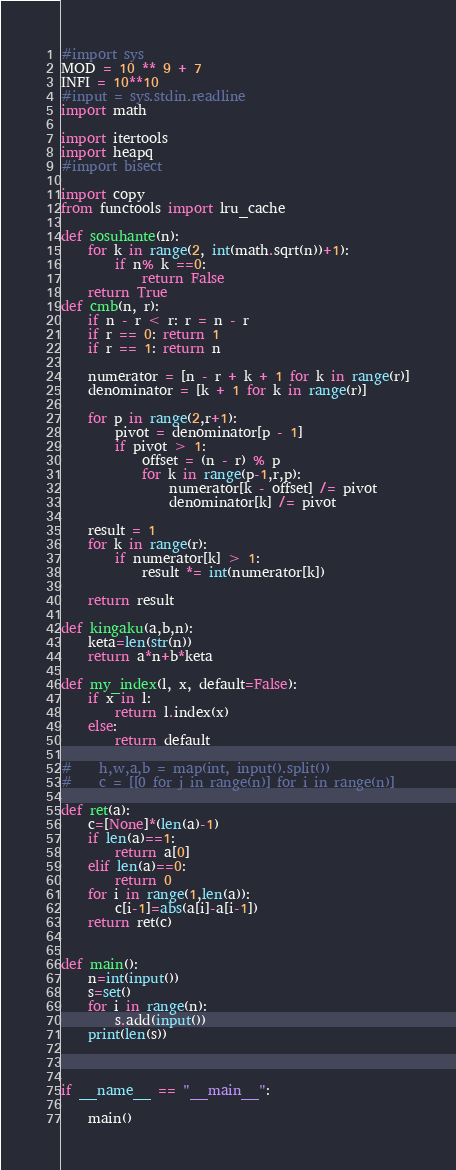Convert code to text. <code><loc_0><loc_0><loc_500><loc_500><_Python_>#import sys
MOD = 10 ** 9 + 7
INFI = 10**10
#input = sys.stdin.readline
import math

import itertools
import heapq
#import bisect

import copy
from functools import lru_cache

def sosuhante(n):
    for k in range(2, int(math.sqrt(n))+1):
        if n% k ==0:
            return False
    return True
def cmb(n, r):
    if n - r < r: r = n - r
    if r == 0: return 1
    if r == 1: return n

    numerator = [n - r + k + 1 for k in range(r)]
    denominator = [k + 1 for k in range(r)]

    for p in range(2,r+1):
        pivot = denominator[p - 1]
        if pivot > 1:
            offset = (n - r) % p
            for k in range(p-1,r,p):
                numerator[k - offset] /= pivot
                denominator[k] /= pivot

    result = 1
    for k in range(r):
        if numerator[k] > 1:
            result *= int(numerator[k])

    return result

def kingaku(a,b,n):
    keta=len(str(n))
    return a*n+b*keta

def my_index(l, x, default=False):
    if x in l:
        return l.index(x)
    else:
        return default

#    h,w,a,b = map(int, input().split())
#    c = [[0 for j in range(n)] for i in range(n)]

def ret(a):
    c=[None]*(len(a)-1)
    if len(a)==1:
        return a[0]
    elif len(a)==0:
        return 0
    for i in range(1,len(a)):
        c[i-1]=abs(a[i]-a[i-1])
    return ret(c)


def main():
    n=int(input())
    s=set()
    for i in range(n):
        s.add(input())
    print(len(s))



if __name__ == "__main__":

    main()</code> 